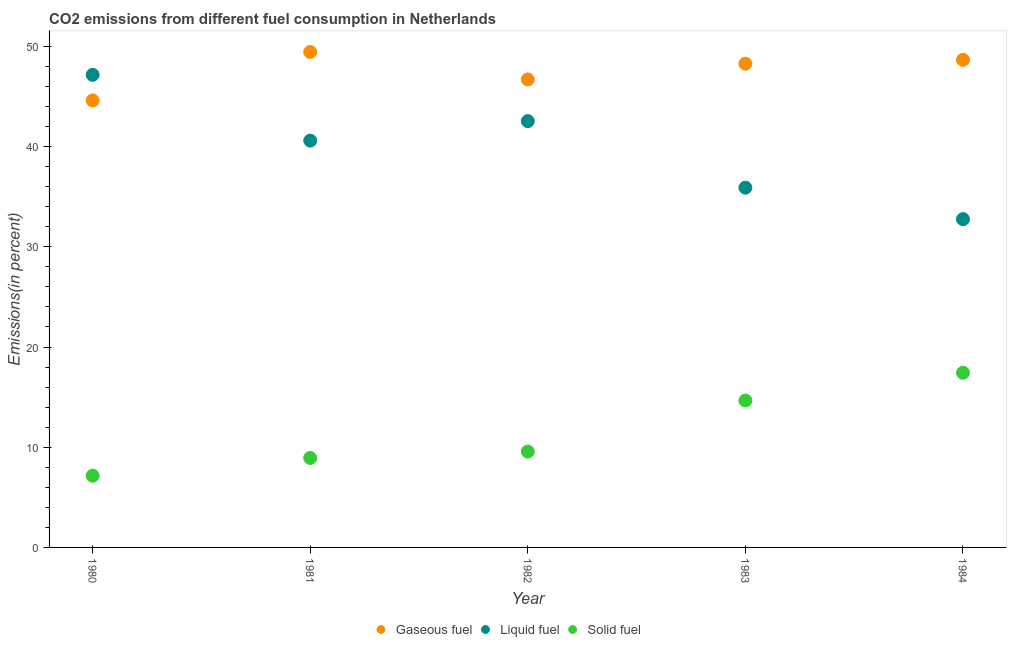How many different coloured dotlines are there?
Give a very brief answer. 3. Is the number of dotlines equal to the number of legend labels?
Provide a short and direct response. Yes. What is the percentage of liquid fuel emission in 1980?
Your answer should be very brief. 47.16. Across all years, what is the maximum percentage of gaseous fuel emission?
Your answer should be very brief. 49.44. Across all years, what is the minimum percentage of gaseous fuel emission?
Offer a terse response. 44.61. In which year was the percentage of liquid fuel emission maximum?
Make the answer very short. 1980. In which year was the percentage of liquid fuel emission minimum?
Keep it short and to the point. 1984. What is the total percentage of solid fuel emission in the graph?
Your answer should be compact. 57.75. What is the difference between the percentage of solid fuel emission in 1981 and that in 1982?
Make the answer very short. -0.64. What is the difference between the percentage of liquid fuel emission in 1983 and the percentage of gaseous fuel emission in 1984?
Keep it short and to the point. -12.76. What is the average percentage of solid fuel emission per year?
Provide a short and direct response. 11.55. In the year 1983, what is the difference between the percentage of gaseous fuel emission and percentage of liquid fuel emission?
Keep it short and to the point. 12.38. In how many years, is the percentage of gaseous fuel emission greater than 46 %?
Your response must be concise. 4. What is the ratio of the percentage of solid fuel emission in 1983 to that in 1984?
Ensure brevity in your answer.  0.84. Is the percentage of gaseous fuel emission in 1980 less than that in 1981?
Offer a very short reply. Yes. Is the difference between the percentage of liquid fuel emission in 1983 and 1984 greater than the difference between the percentage of solid fuel emission in 1983 and 1984?
Give a very brief answer. Yes. What is the difference between the highest and the second highest percentage of gaseous fuel emission?
Your answer should be very brief. 0.78. What is the difference between the highest and the lowest percentage of solid fuel emission?
Ensure brevity in your answer.  10.27. Is the percentage of gaseous fuel emission strictly greater than the percentage of liquid fuel emission over the years?
Give a very brief answer. No. What is the difference between two consecutive major ticks on the Y-axis?
Your response must be concise. 10. Does the graph contain grids?
Offer a terse response. No. How many legend labels are there?
Keep it short and to the point. 3. What is the title of the graph?
Your response must be concise. CO2 emissions from different fuel consumption in Netherlands. What is the label or title of the X-axis?
Your response must be concise. Year. What is the label or title of the Y-axis?
Make the answer very short. Emissions(in percent). What is the Emissions(in percent) in Gaseous fuel in 1980?
Provide a succinct answer. 44.61. What is the Emissions(in percent) in Liquid fuel in 1980?
Your answer should be compact. 47.16. What is the Emissions(in percent) of Solid fuel in 1980?
Keep it short and to the point. 7.16. What is the Emissions(in percent) of Gaseous fuel in 1981?
Provide a succinct answer. 49.44. What is the Emissions(in percent) in Liquid fuel in 1981?
Offer a terse response. 40.6. What is the Emissions(in percent) in Solid fuel in 1981?
Give a very brief answer. 8.93. What is the Emissions(in percent) in Gaseous fuel in 1982?
Keep it short and to the point. 46.7. What is the Emissions(in percent) in Liquid fuel in 1982?
Offer a very short reply. 42.54. What is the Emissions(in percent) of Solid fuel in 1982?
Your answer should be very brief. 9.57. What is the Emissions(in percent) in Gaseous fuel in 1983?
Your answer should be very brief. 48.28. What is the Emissions(in percent) of Liquid fuel in 1983?
Give a very brief answer. 35.9. What is the Emissions(in percent) in Solid fuel in 1983?
Offer a very short reply. 14.66. What is the Emissions(in percent) of Gaseous fuel in 1984?
Your answer should be very brief. 48.66. What is the Emissions(in percent) in Liquid fuel in 1984?
Make the answer very short. 32.76. What is the Emissions(in percent) in Solid fuel in 1984?
Provide a short and direct response. 17.43. Across all years, what is the maximum Emissions(in percent) in Gaseous fuel?
Give a very brief answer. 49.44. Across all years, what is the maximum Emissions(in percent) of Liquid fuel?
Your response must be concise. 47.16. Across all years, what is the maximum Emissions(in percent) in Solid fuel?
Provide a succinct answer. 17.43. Across all years, what is the minimum Emissions(in percent) of Gaseous fuel?
Provide a short and direct response. 44.61. Across all years, what is the minimum Emissions(in percent) of Liquid fuel?
Make the answer very short. 32.76. Across all years, what is the minimum Emissions(in percent) of Solid fuel?
Your answer should be very brief. 7.16. What is the total Emissions(in percent) of Gaseous fuel in the graph?
Offer a very short reply. 237.7. What is the total Emissions(in percent) of Liquid fuel in the graph?
Your answer should be very brief. 198.97. What is the total Emissions(in percent) of Solid fuel in the graph?
Give a very brief answer. 57.75. What is the difference between the Emissions(in percent) in Gaseous fuel in 1980 and that in 1981?
Keep it short and to the point. -4.83. What is the difference between the Emissions(in percent) in Liquid fuel in 1980 and that in 1981?
Ensure brevity in your answer.  6.57. What is the difference between the Emissions(in percent) in Solid fuel in 1980 and that in 1981?
Make the answer very short. -1.77. What is the difference between the Emissions(in percent) in Gaseous fuel in 1980 and that in 1982?
Make the answer very short. -2.1. What is the difference between the Emissions(in percent) in Liquid fuel in 1980 and that in 1982?
Provide a succinct answer. 4.62. What is the difference between the Emissions(in percent) of Solid fuel in 1980 and that in 1982?
Ensure brevity in your answer.  -2.41. What is the difference between the Emissions(in percent) in Gaseous fuel in 1980 and that in 1983?
Provide a succinct answer. -3.67. What is the difference between the Emissions(in percent) in Liquid fuel in 1980 and that in 1983?
Provide a succinct answer. 11.26. What is the difference between the Emissions(in percent) in Solid fuel in 1980 and that in 1983?
Your answer should be compact. -7.5. What is the difference between the Emissions(in percent) of Gaseous fuel in 1980 and that in 1984?
Ensure brevity in your answer.  -4.05. What is the difference between the Emissions(in percent) of Liquid fuel in 1980 and that in 1984?
Your answer should be compact. 14.4. What is the difference between the Emissions(in percent) of Solid fuel in 1980 and that in 1984?
Make the answer very short. -10.27. What is the difference between the Emissions(in percent) of Gaseous fuel in 1981 and that in 1982?
Provide a succinct answer. 2.74. What is the difference between the Emissions(in percent) of Liquid fuel in 1981 and that in 1982?
Your answer should be very brief. -1.95. What is the difference between the Emissions(in percent) in Solid fuel in 1981 and that in 1982?
Ensure brevity in your answer.  -0.64. What is the difference between the Emissions(in percent) of Gaseous fuel in 1981 and that in 1983?
Provide a succinct answer. 1.16. What is the difference between the Emissions(in percent) of Liquid fuel in 1981 and that in 1983?
Give a very brief answer. 4.7. What is the difference between the Emissions(in percent) of Solid fuel in 1981 and that in 1983?
Offer a terse response. -5.73. What is the difference between the Emissions(in percent) in Gaseous fuel in 1981 and that in 1984?
Provide a short and direct response. 0.78. What is the difference between the Emissions(in percent) in Liquid fuel in 1981 and that in 1984?
Provide a succinct answer. 7.83. What is the difference between the Emissions(in percent) of Solid fuel in 1981 and that in 1984?
Provide a succinct answer. -8.5. What is the difference between the Emissions(in percent) in Gaseous fuel in 1982 and that in 1983?
Your answer should be compact. -1.58. What is the difference between the Emissions(in percent) in Liquid fuel in 1982 and that in 1983?
Your response must be concise. 6.64. What is the difference between the Emissions(in percent) of Solid fuel in 1982 and that in 1983?
Provide a short and direct response. -5.1. What is the difference between the Emissions(in percent) in Gaseous fuel in 1982 and that in 1984?
Make the answer very short. -1.96. What is the difference between the Emissions(in percent) in Liquid fuel in 1982 and that in 1984?
Offer a very short reply. 9.78. What is the difference between the Emissions(in percent) in Solid fuel in 1982 and that in 1984?
Your answer should be compact. -7.86. What is the difference between the Emissions(in percent) of Gaseous fuel in 1983 and that in 1984?
Offer a terse response. -0.38. What is the difference between the Emissions(in percent) of Liquid fuel in 1983 and that in 1984?
Ensure brevity in your answer.  3.14. What is the difference between the Emissions(in percent) of Solid fuel in 1983 and that in 1984?
Ensure brevity in your answer.  -2.77. What is the difference between the Emissions(in percent) of Gaseous fuel in 1980 and the Emissions(in percent) of Liquid fuel in 1981?
Make the answer very short. 4.01. What is the difference between the Emissions(in percent) of Gaseous fuel in 1980 and the Emissions(in percent) of Solid fuel in 1981?
Your answer should be compact. 35.68. What is the difference between the Emissions(in percent) in Liquid fuel in 1980 and the Emissions(in percent) in Solid fuel in 1981?
Offer a terse response. 38.23. What is the difference between the Emissions(in percent) of Gaseous fuel in 1980 and the Emissions(in percent) of Liquid fuel in 1982?
Ensure brevity in your answer.  2.06. What is the difference between the Emissions(in percent) of Gaseous fuel in 1980 and the Emissions(in percent) of Solid fuel in 1982?
Your answer should be very brief. 35.04. What is the difference between the Emissions(in percent) in Liquid fuel in 1980 and the Emissions(in percent) in Solid fuel in 1982?
Offer a terse response. 37.6. What is the difference between the Emissions(in percent) in Gaseous fuel in 1980 and the Emissions(in percent) in Liquid fuel in 1983?
Make the answer very short. 8.71. What is the difference between the Emissions(in percent) of Gaseous fuel in 1980 and the Emissions(in percent) of Solid fuel in 1983?
Keep it short and to the point. 29.95. What is the difference between the Emissions(in percent) in Liquid fuel in 1980 and the Emissions(in percent) in Solid fuel in 1983?
Offer a very short reply. 32.5. What is the difference between the Emissions(in percent) of Gaseous fuel in 1980 and the Emissions(in percent) of Liquid fuel in 1984?
Your answer should be very brief. 11.85. What is the difference between the Emissions(in percent) in Gaseous fuel in 1980 and the Emissions(in percent) in Solid fuel in 1984?
Give a very brief answer. 27.18. What is the difference between the Emissions(in percent) of Liquid fuel in 1980 and the Emissions(in percent) of Solid fuel in 1984?
Offer a terse response. 29.73. What is the difference between the Emissions(in percent) in Gaseous fuel in 1981 and the Emissions(in percent) in Liquid fuel in 1982?
Keep it short and to the point. 6.9. What is the difference between the Emissions(in percent) in Gaseous fuel in 1981 and the Emissions(in percent) in Solid fuel in 1982?
Your response must be concise. 39.88. What is the difference between the Emissions(in percent) in Liquid fuel in 1981 and the Emissions(in percent) in Solid fuel in 1982?
Give a very brief answer. 31.03. What is the difference between the Emissions(in percent) in Gaseous fuel in 1981 and the Emissions(in percent) in Liquid fuel in 1983?
Ensure brevity in your answer.  13.54. What is the difference between the Emissions(in percent) in Gaseous fuel in 1981 and the Emissions(in percent) in Solid fuel in 1983?
Your response must be concise. 34.78. What is the difference between the Emissions(in percent) in Liquid fuel in 1981 and the Emissions(in percent) in Solid fuel in 1983?
Your answer should be compact. 25.93. What is the difference between the Emissions(in percent) of Gaseous fuel in 1981 and the Emissions(in percent) of Liquid fuel in 1984?
Your answer should be very brief. 16.68. What is the difference between the Emissions(in percent) in Gaseous fuel in 1981 and the Emissions(in percent) in Solid fuel in 1984?
Your answer should be compact. 32.01. What is the difference between the Emissions(in percent) in Liquid fuel in 1981 and the Emissions(in percent) in Solid fuel in 1984?
Offer a very short reply. 23.17. What is the difference between the Emissions(in percent) of Gaseous fuel in 1982 and the Emissions(in percent) of Liquid fuel in 1983?
Make the answer very short. 10.8. What is the difference between the Emissions(in percent) in Gaseous fuel in 1982 and the Emissions(in percent) in Solid fuel in 1983?
Your answer should be compact. 32.04. What is the difference between the Emissions(in percent) of Liquid fuel in 1982 and the Emissions(in percent) of Solid fuel in 1983?
Your response must be concise. 27.88. What is the difference between the Emissions(in percent) in Gaseous fuel in 1982 and the Emissions(in percent) in Liquid fuel in 1984?
Offer a very short reply. 13.94. What is the difference between the Emissions(in percent) in Gaseous fuel in 1982 and the Emissions(in percent) in Solid fuel in 1984?
Offer a terse response. 29.27. What is the difference between the Emissions(in percent) in Liquid fuel in 1982 and the Emissions(in percent) in Solid fuel in 1984?
Give a very brief answer. 25.11. What is the difference between the Emissions(in percent) in Gaseous fuel in 1983 and the Emissions(in percent) in Liquid fuel in 1984?
Keep it short and to the point. 15.52. What is the difference between the Emissions(in percent) in Gaseous fuel in 1983 and the Emissions(in percent) in Solid fuel in 1984?
Provide a succinct answer. 30.85. What is the difference between the Emissions(in percent) in Liquid fuel in 1983 and the Emissions(in percent) in Solid fuel in 1984?
Ensure brevity in your answer.  18.47. What is the average Emissions(in percent) in Gaseous fuel per year?
Offer a very short reply. 47.54. What is the average Emissions(in percent) in Liquid fuel per year?
Your response must be concise. 39.79. What is the average Emissions(in percent) of Solid fuel per year?
Provide a short and direct response. 11.55. In the year 1980, what is the difference between the Emissions(in percent) of Gaseous fuel and Emissions(in percent) of Liquid fuel?
Give a very brief answer. -2.55. In the year 1980, what is the difference between the Emissions(in percent) in Gaseous fuel and Emissions(in percent) in Solid fuel?
Your response must be concise. 37.45. In the year 1980, what is the difference between the Emissions(in percent) of Liquid fuel and Emissions(in percent) of Solid fuel?
Your response must be concise. 40. In the year 1981, what is the difference between the Emissions(in percent) in Gaseous fuel and Emissions(in percent) in Liquid fuel?
Your response must be concise. 8.85. In the year 1981, what is the difference between the Emissions(in percent) of Gaseous fuel and Emissions(in percent) of Solid fuel?
Keep it short and to the point. 40.51. In the year 1981, what is the difference between the Emissions(in percent) of Liquid fuel and Emissions(in percent) of Solid fuel?
Your answer should be very brief. 31.67. In the year 1982, what is the difference between the Emissions(in percent) of Gaseous fuel and Emissions(in percent) of Liquid fuel?
Make the answer very short. 4.16. In the year 1982, what is the difference between the Emissions(in percent) of Gaseous fuel and Emissions(in percent) of Solid fuel?
Give a very brief answer. 37.14. In the year 1982, what is the difference between the Emissions(in percent) in Liquid fuel and Emissions(in percent) in Solid fuel?
Provide a succinct answer. 32.98. In the year 1983, what is the difference between the Emissions(in percent) in Gaseous fuel and Emissions(in percent) in Liquid fuel?
Keep it short and to the point. 12.38. In the year 1983, what is the difference between the Emissions(in percent) of Gaseous fuel and Emissions(in percent) of Solid fuel?
Provide a short and direct response. 33.62. In the year 1983, what is the difference between the Emissions(in percent) of Liquid fuel and Emissions(in percent) of Solid fuel?
Your response must be concise. 21.24. In the year 1984, what is the difference between the Emissions(in percent) in Gaseous fuel and Emissions(in percent) in Liquid fuel?
Provide a succinct answer. 15.9. In the year 1984, what is the difference between the Emissions(in percent) of Gaseous fuel and Emissions(in percent) of Solid fuel?
Your answer should be very brief. 31.23. In the year 1984, what is the difference between the Emissions(in percent) of Liquid fuel and Emissions(in percent) of Solid fuel?
Keep it short and to the point. 15.33. What is the ratio of the Emissions(in percent) in Gaseous fuel in 1980 to that in 1981?
Your answer should be very brief. 0.9. What is the ratio of the Emissions(in percent) in Liquid fuel in 1980 to that in 1981?
Your response must be concise. 1.16. What is the ratio of the Emissions(in percent) in Solid fuel in 1980 to that in 1981?
Your answer should be very brief. 0.8. What is the ratio of the Emissions(in percent) of Gaseous fuel in 1980 to that in 1982?
Give a very brief answer. 0.96. What is the ratio of the Emissions(in percent) of Liquid fuel in 1980 to that in 1982?
Offer a terse response. 1.11. What is the ratio of the Emissions(in percent) of Solid fuel in 1980 to that in 1982?
Provide a succinct answer. 0.75. What is the ratio of the Emissions(in percent) of Gaseous fuel in 1980 to that in 1983?
Offer a terse response. 0.92. What is the ratio of the Emissions(in percent) of Liquid fuel in 1980 to that in 1983?
Ensure brevity in your answer.  1.31. What is the ratio of the Emissions(in percent) of Solid fuel in 1980 to that in 1983?
Provide a succinct answer. 0.49. What is the ratio of the Emissions(in percent) of Gaseous fuel in 1980 to that in 1984?
Provide a short and direct response. 0.92. What is the ratio of the Emissions(in percent) in Liquid fuel in 1980 to that in 1984?
Keep it short and to the point. 1.44. What is the ratio of the Emissions(in percent) of Solid fuel in 1980 to that in 1984?
Ensure brevity in your answer.  0.41. What is the ratio of the Emissions(in percent) in Gaseous fuel in 1981 to that in 1982?
Your answer should be very brief. 1.06. What is the ratio of the Emissions(in percent) in Liquid fuel in 1981 to that in 1982?
Your answer should be very brief. 0.95. What is the ratio of the Emissions(in percent) in Solid fuel in 1981 to that in 1982?
Offer a terse response. 0.93. What is the ratio of the Emissions(in percent) in Gaseous fuel in 1981 to that in 1983?
Your answer should be very brief. 1.02. What is the ratio of the Emissions(in percent) of Liquid fuel in 1981 to that in 1983?
Your answer should be very brief. 1.13. What is the ratio of the Emissions(in percent) of Solid fuel in 1981 to that in 1983?
Your answer should be compact. 0.61. What is the ratio of the Emissions(in percent) in Liquid fuel in 1981 to that in 1984?
Your answer should be very brief. 1.24. What is the ratio of the Emissions(in percent) in Solid fuel in 1981 to that in 1984?
Provide a short and direct response. 0.51. What is the ratio of the Emissions(in percent) of Gaseous fuel in 1982 to that in 1983?
Make the answer very short. 0.97. What is the ratio of the Emissions(in percent) of Liquid fuel in 1982 to that in 1983?
Offer a very short reply. 1.19. What is the ratio of the Emissions(in percent) in Solid fuel in 1982 to that in 1983?
Offer a very short reply. 0.65. What is the ratio of the Emissions(in percent) in Gaseous fuel in 1982 to that in 1984?
Give a very brief answer. 0.96. What is the ratio of the Emissions(in percent) in Liquid fuel in 1982 to that in 1984?
Keep it short and to the point. 1.3. What is the ratio of the Emissions(in percent) of Solid fuel in 1982 to that in 1984?
Offer a terse response. 0.55. What is the ratio of the Emissions(in percent) in Liquid fuel in 1983 to that in 1984?
Your response must be concise. 1.1. What is the ratio of the Emissions(in percent) in Solid fuel in 1983 to that in 1984?
Provide a succinct answer. 0.84. What is the difference between the highest and the second highest Emissions(in percent) in Gaseous fuel?
Provide a succinct answer. 0.78. What is the difference between the highest and the second highest Emissions(in percent) of Liquid fuel?
Make the answer very short. 4.62. What is the difference between the highest and the second highest Emissions(in percent) in Solid fuel?
Offer a very short reply. 2.77. What is the difference between the highest and the lowest Emissions(in percent) of Gaseous fuel?
Keep it short and to the point. 4.83. What is the difference between the highest and the lowest Emissions(in percent) in Liquid fuel?
Your response must be concise. 14.4. What is the difference between the highest and the lowest Emissions(in percent) of Solid fuel?
Ensure brevity in your answer.  10.27. 